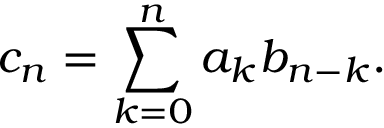Convert formula to latex. <formula><loc_0><loc_0><loc_500><loc_500>c _ { n } = \sum _ { k = 0 } ^ { n } a _ { k } b _ { n - k } .</formula> 